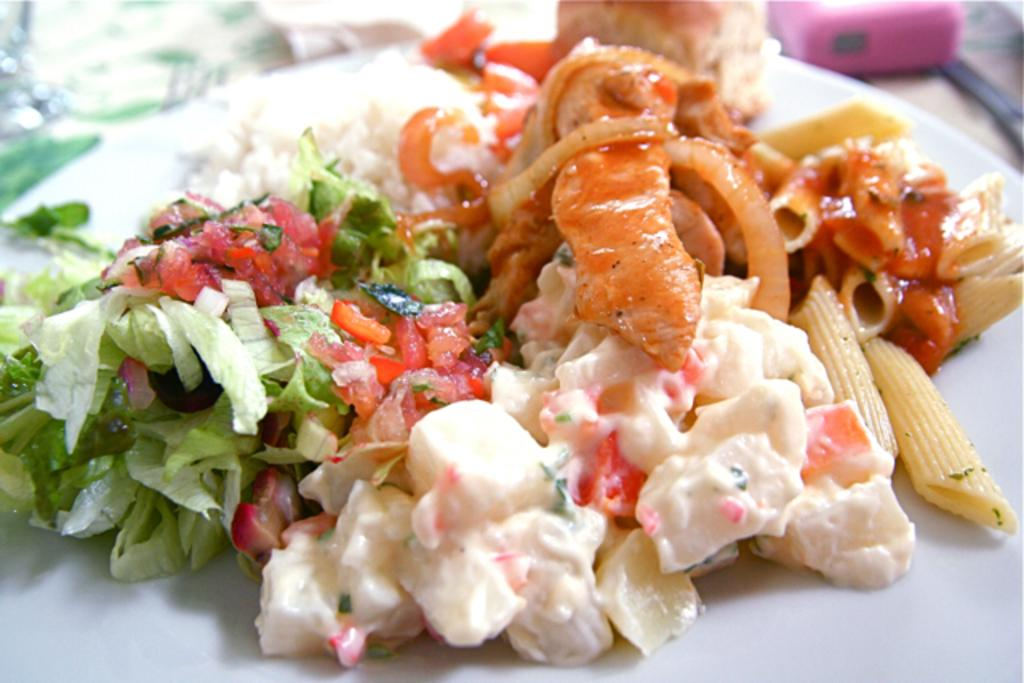What type of food can be seen in the image? There is food in the image, but the specific type cannot be determined from the facts provided. What colors are present in the food? The food has white, red, and green colors. What color is the plate that the food is on? The plate is white. Can you see a person eating the food in the image? There is no person present in the image, so it cannot be determined if someone is eating the food. What type of mint is used as a garnish on the food in the image? There is no mint present in the image, and the specific type of food is not mentioned, so it cannot be determined if mint is used as a garnish. 